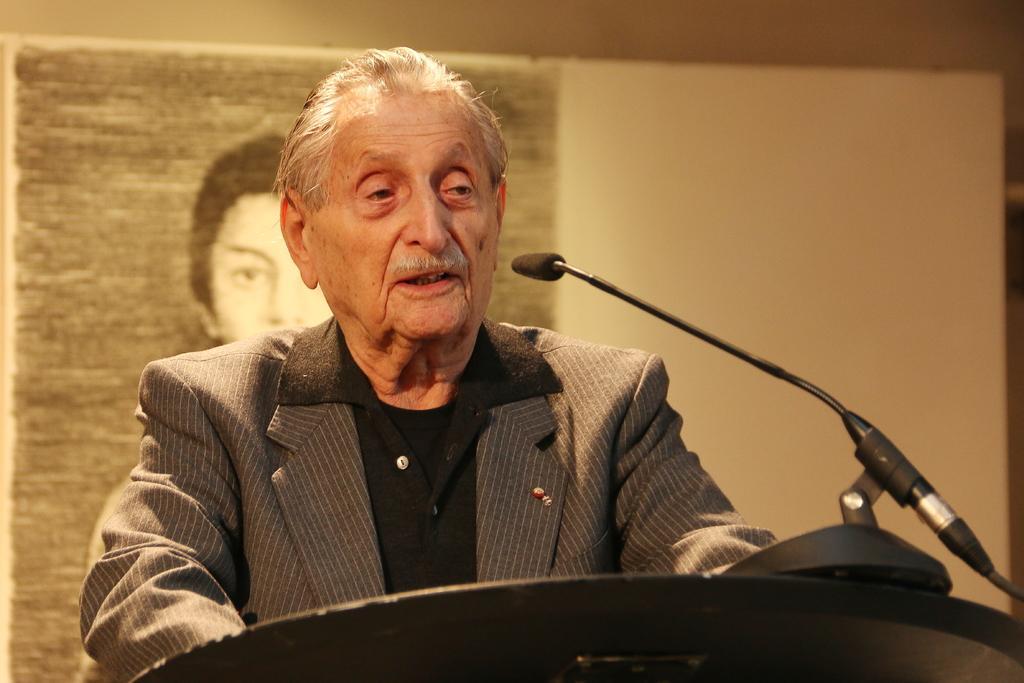Describe this image in one or two sentences. A person is standing wearing a suit. There is a microphone and its stand present in front of him. Behind him there is a photo of a person. 